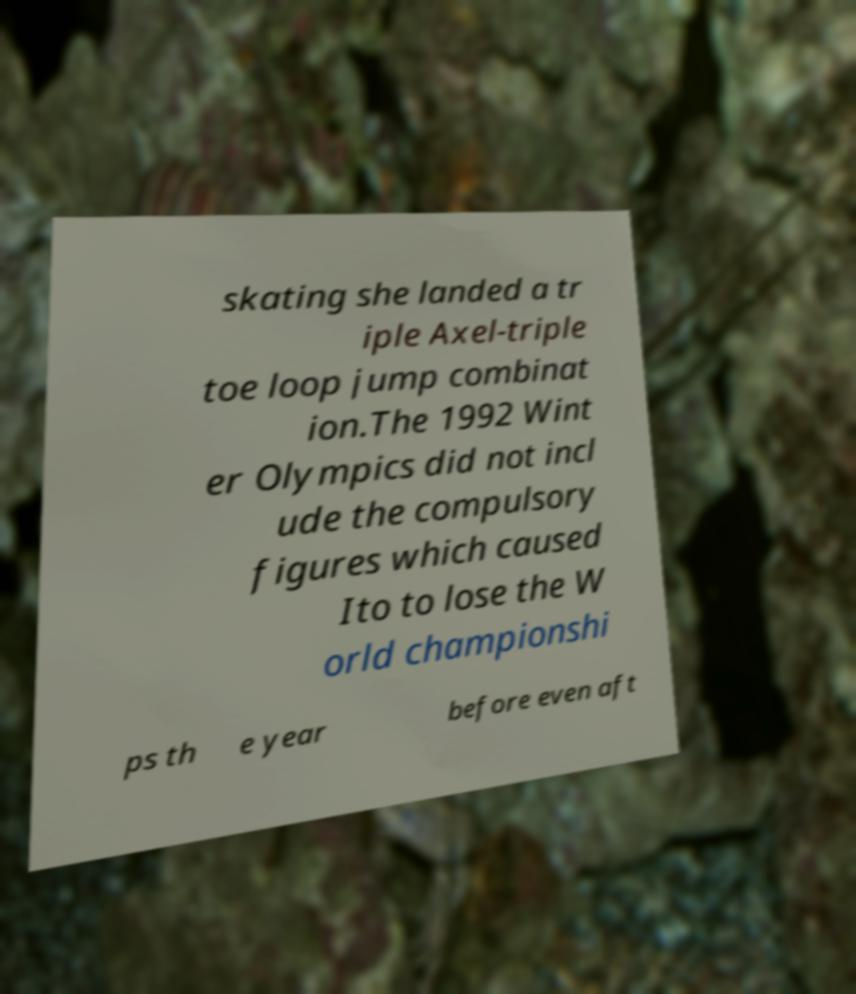Could you assist in decoding the text presented in this image and type it out clearly? skating she landed a tr iple Axel-triple toe loop jump combinat ion.The 1992 Wint er Olympics did not incl ude the compulsory figures which caused Ito to lose the W orld championshi ps th e year before even aft 